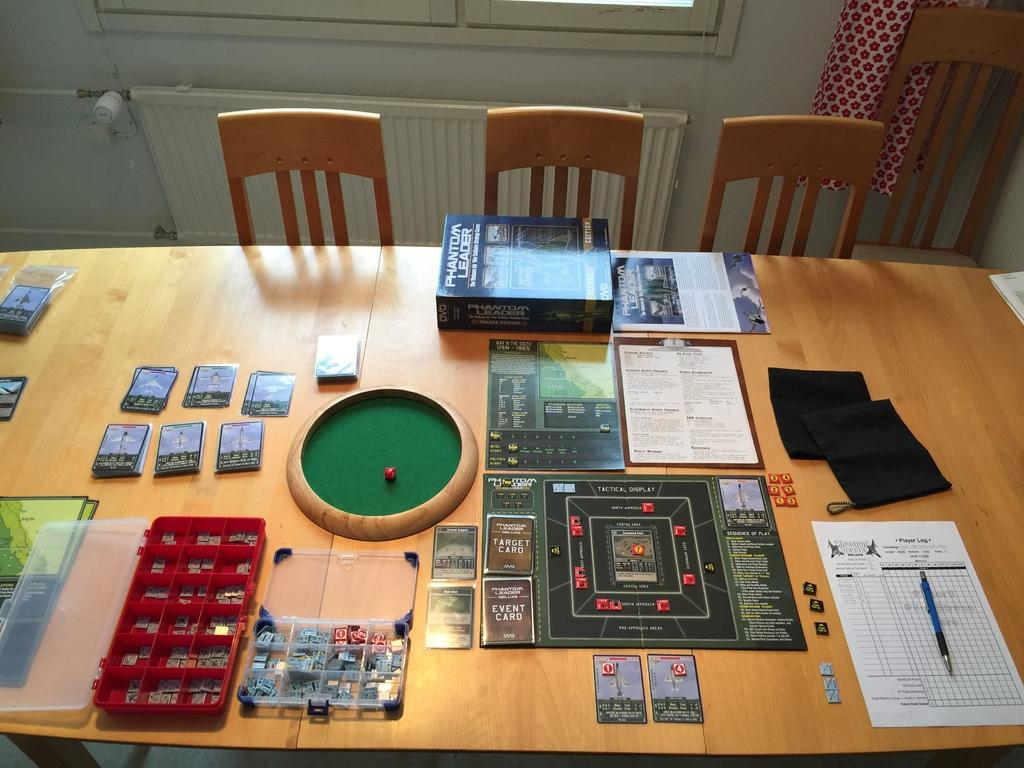What type of furniture is visible in the image? There are chairs and tables in the image. What items can be seen on the tables? Books, papers, and pens are on the tables. Are there any other objects on the tables? Yes, there are other objects on the tables. What can be seen in the background of the image? There is a cloth and a wall in the background of the image. What type of cord is being used to hold the position of the stage in the image? There is no stage or cord present in the image. 